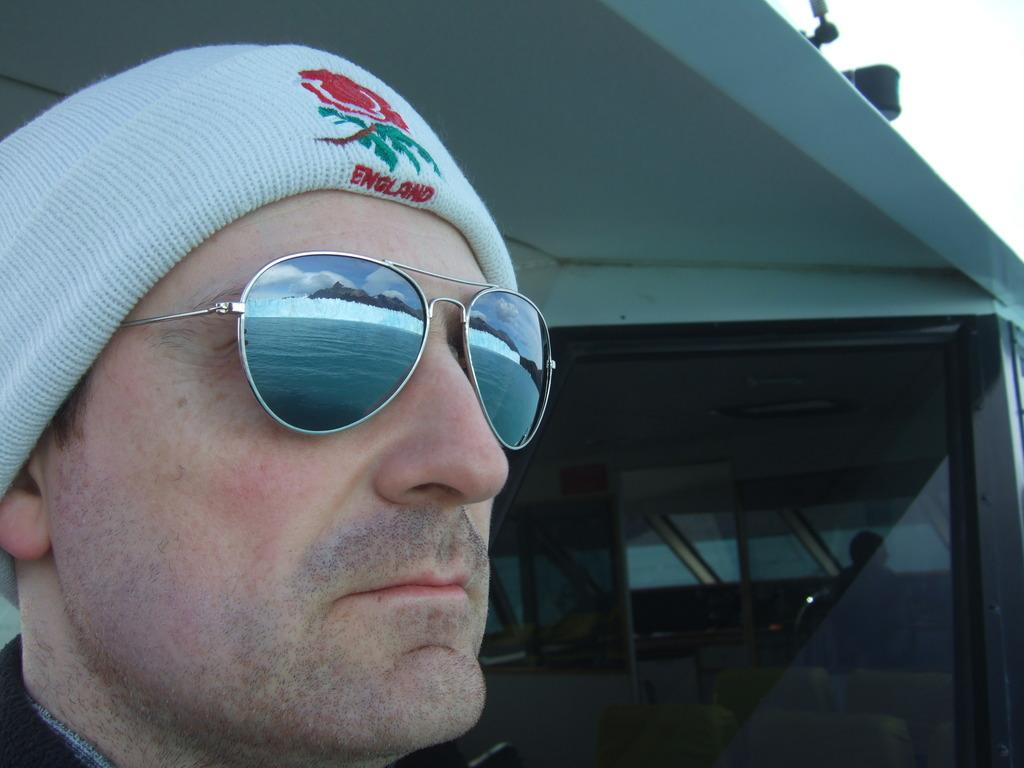Who is present in the image? There is a man in the image. What accessories is the man wearing? The man is wearing sunglasses and a cap. What color is the cap the man is wearing? The cap is white in color. What type of structure can be seen in the image? There is a glass window in the image. Where is the throne located in the image? There is no throne present in the image. What letters can be seen on the man's shirt in the image? The provided facts do not mention any letters on the man's shirt, so we cannot answer this question. --- Facts: 1. There is a car in the image. 2. The car is red. 3. The car has four wheels. 4. There is a road in the image. 5. The road is paved. Absurd Topics: parrot, sand, mountain Conversation: What vehicle is in the image? There is a car in the image. What color is the car? The car is red. How many wheels does the car have? The car has four wheels. What type of surface can be seen in the image? There is a road in the image, and it is paved. Reasoning: Let's think step by step in order to produce the conversation. We start by identifying the main subject in the image, which is the car. Then, we describe the color of the car to provide more detail about its appearance. Next, we focus on the number of wheels the car has to give a sense of its size and structure. Finally, we mention the road and its paved surface as a notable feature in the image. Absurd Question/Answer: Can you see a parrot perched on the car's roof in the image? No, there is no parrot present in the image. Is the car driving on a sandy road in the image? No, the road in the image is paved, not sandy. 